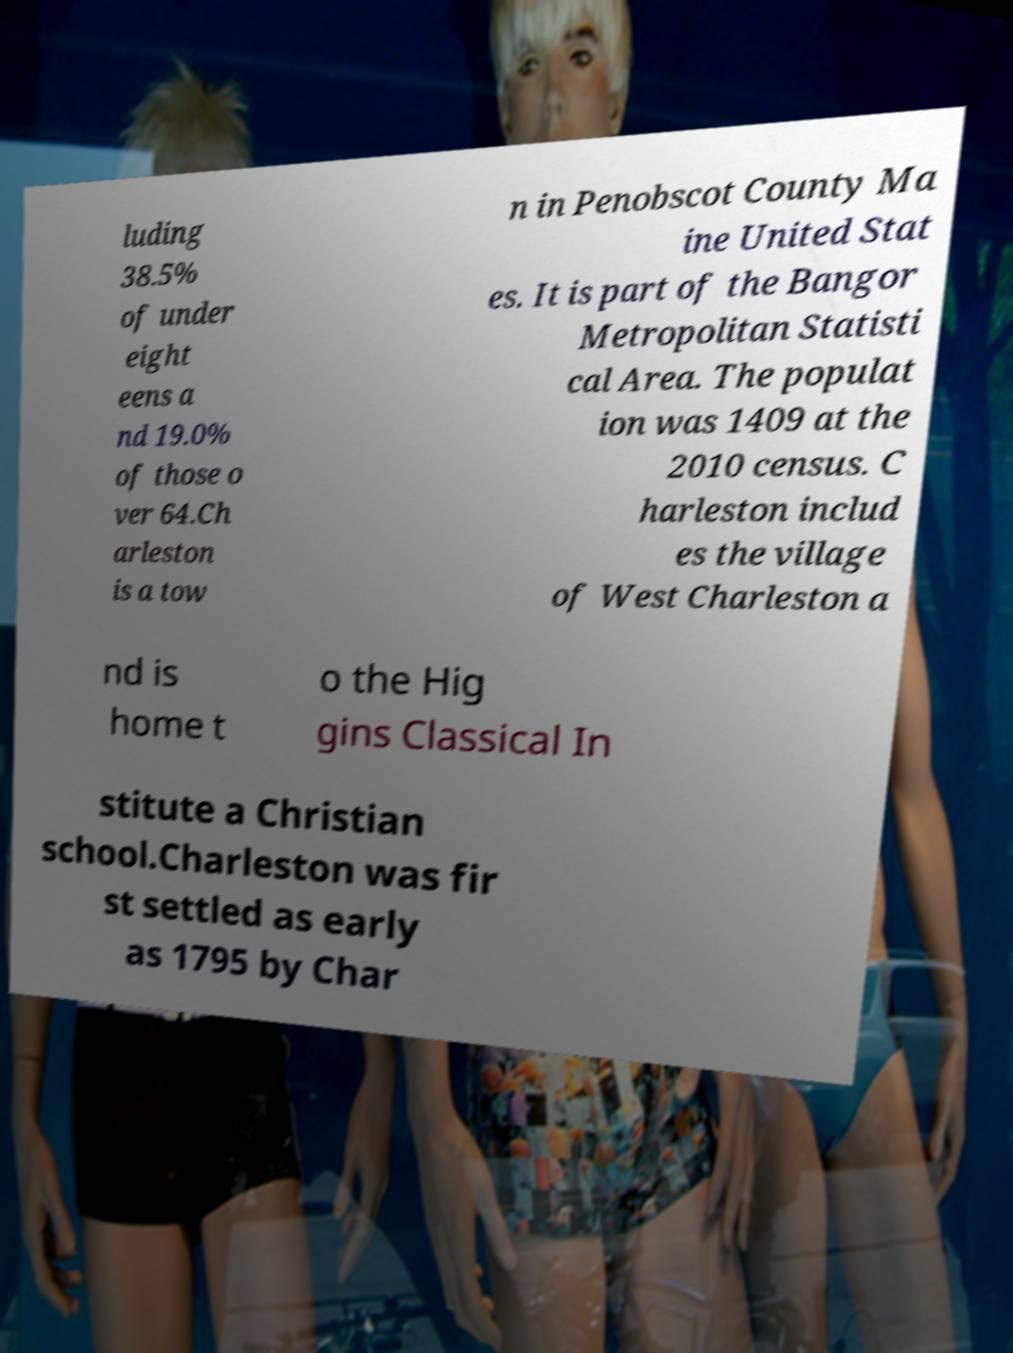What messages or text are displayed in this image? I need them in a readable, typed format. luding 38.5% of under eight eens a nd 19.0% of those o ver 64.Ch arleston is a tow n in Penobscot County Ma ine United Stat es. It is part of the Bangor Metropolitan Statisti cal Area. The populat ion was 1409 at the 2010 census. C harleston includ es the village of West Charleston a nd is home t o the Hig gins Classical In stitute a Christian school.Charleston was fir st settled as early as 1795 by Char 